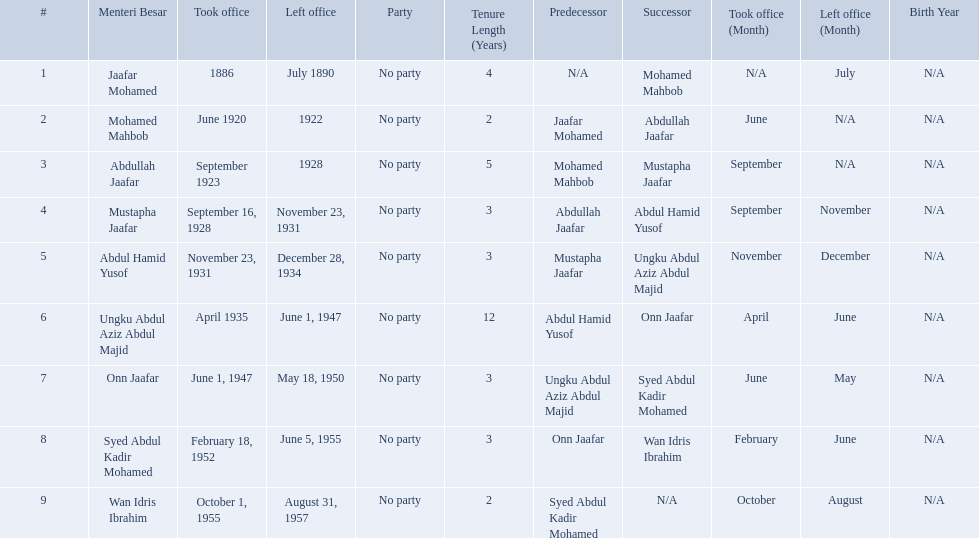Who were the menteri besar of johor? Jaafar Mohamed, Mohamed Mahbob, Abdullah Jaafar, Mustapha Jaafar, Abdul Hamid Yusof, Ungku Abdul Aziz Abdul Majid, Onn Jaafar, Syed Abdul Kadir Mohamed, Wan Idris Ibrahim. Who served the longest? Ungku Abdul Aziz Abdul Majid. Who were all of the menteri besars? Jaafar Mohamed, Mohamed Mahbob, Abdullah Jaafar, Mustapha Jaafar, Abdul Hamid Yusof, Ungku Abdul Aziz Abdul Majid, Onn Jaafar, Syed Abdul Kadir Mohamed, Wan Idris Ibrahim. When did they take office? 1886, June 1920, September 1923, September 16, 1928, November 23, 1931, April 1935, June 1, 1947, February 18, 1952, October 1, 1955. And when did they leave? July 1890, 1922, 1928, November 23, 1931, December 28, 1934, June 1, 1947, May 18, 1950, June 5, 1955, August 31, 1957. Now, who was in office for less than four years? Mohamed Mahbob. Which menteri besars took office in the 1920's? Mohamed Mahbob, Abdullah Jaafar, Mustapha Jaafar. Of those men, who was only in office for 2 years? Mohamed Mahbob. 